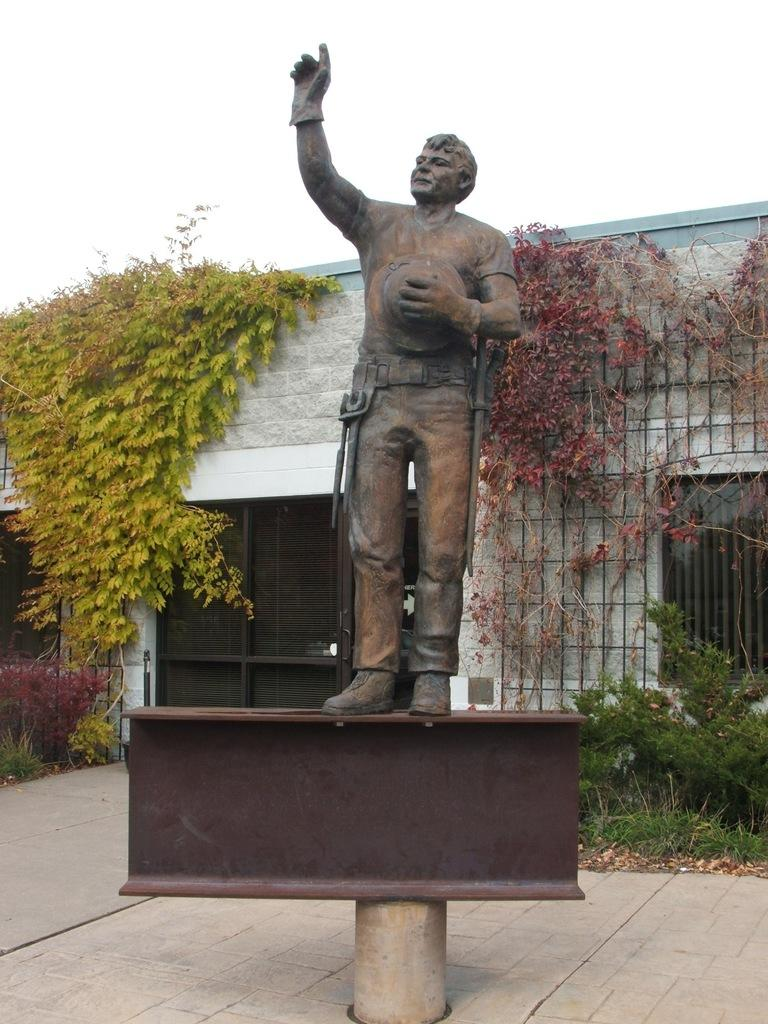What is the main subject of the image? There is a statue of a person in the image. What can be seen in the background of the image? There are plants, a building, and the sky visible in the background of the image. What type of box is being used for income in the image? There is no box or mention of income in the image; it features a statue of a person with a background of plants, a building, and the sky. 